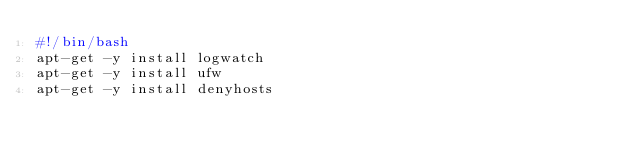<code> <loc_0><loc_0><loc_500><loc_500><_Bash_>#!/bin/bash
apt-get -y install logwatch
apt-get -y install ufw
apt-get -y install denyhosts</code> 